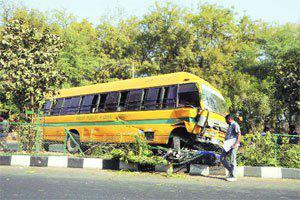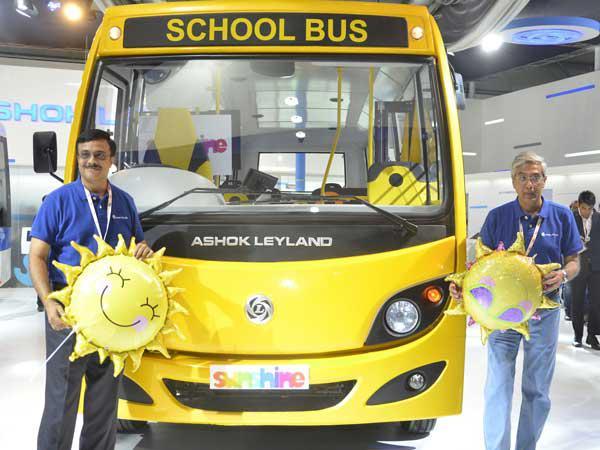The first image is the image on the left, the second image is the image on the right. For the images shown, is this caption "The left and right image contains the same number of  yellow buses." true? Answer yes or no. Yes. The first image is the image on the left, the second image is the image on the right. Considering the images on both sides, is "At least one bus is not crashed." valid? Answer yes or no. Yes. 